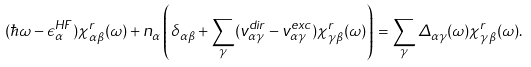<formula> <loc_0><loc_0><loc_500><loc_500>( \hbar { \omega } - \epsilon _ { \alpha } ^ { H F } ) \chi ^ { r } _ { \alpha \beta } ( \omega ) + n _ { \alpha } \left ( \delta _ { \alpha \beta } + \sum _ { \gamma } ( v ^ { d i r } _ { \alpha \gamma } - v ^ { e x c } _ { \alpha \gamma } ) \chi ^ { r } _ { \gamma \beta } ( \omega ) \right ) = \sum _ { \gamma } \Delta _ { \alpha \gamma } ( \omega ) \chi _ { \gamma \beta } ^ { r } ( \omega ) .</formula> 